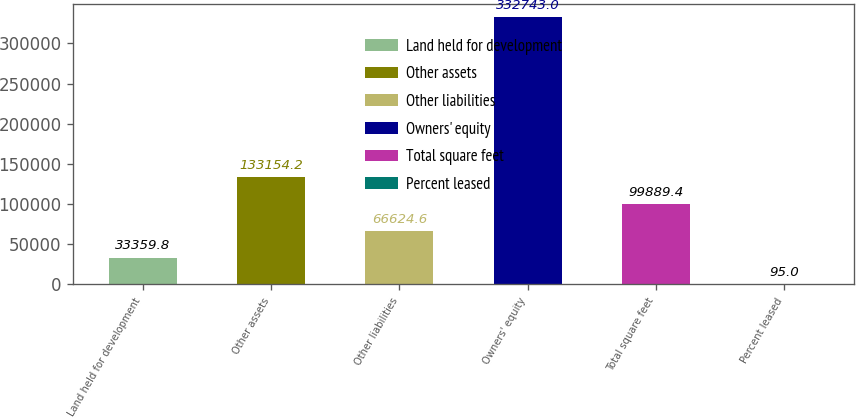Convert chart. <chart><loc_0><loc_0><loc_500><loc_500><bar_chart><fcel>Land held for development<fcel>Other assets<fcel>Other liabilities<fcel>Owners' equity<fcel>Total square feet<fcel>Percent leased<nl><fcel>33359.8<fcel>133154<fcel>66624.6<fcel>332743<fcel>99889.4<fcel>95<nl></chart> 